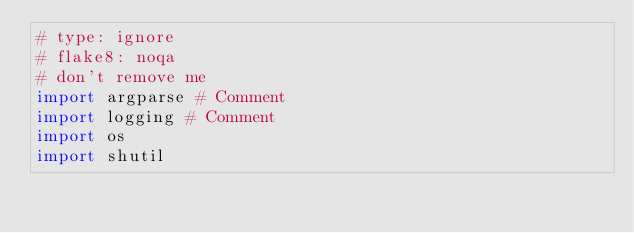<code> <loc_0><loc_0><loc_500><loc_500><_Python_># type: ignore
# flake8: noqa
# don't remove me
import argparse # Comment
import logging # Comment
import os
import shutil</code> 